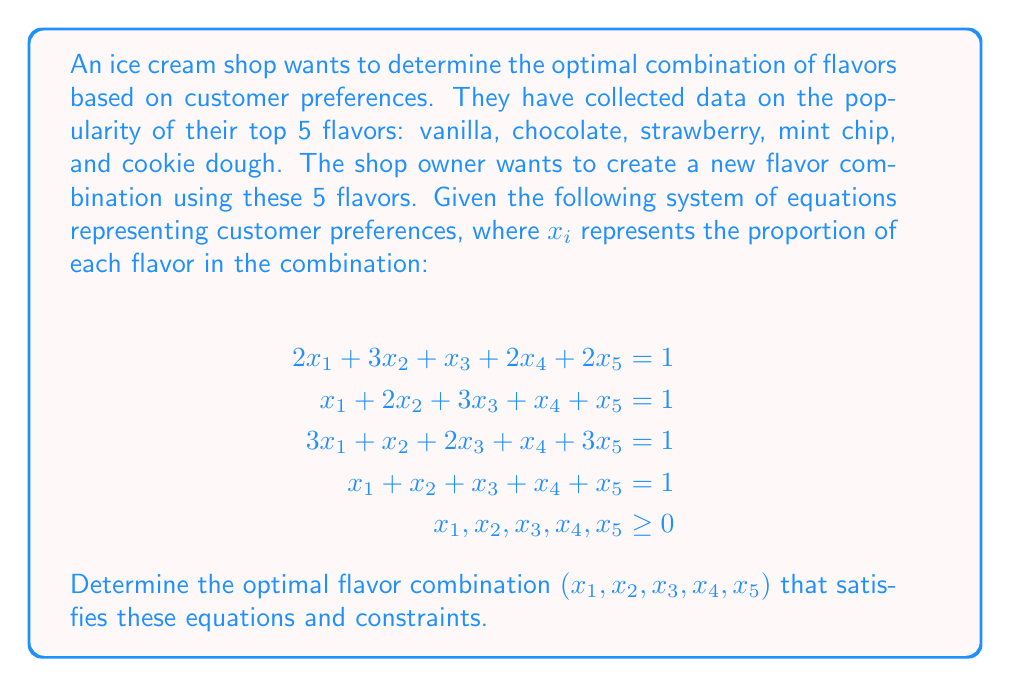Show me your answer to this math problem. To solve this inverse problem and find the optimal flavor combination, we'll use the method of least squares, as we have an overdetermined system (more equations than unknowns).

Step 1: Set up the system in matrix form $Ax = b$:

$$A = \begin{bmatrix}
2 & 3 & 1 & 2 & 2 \\
1 & 2 & 3 & 1 & 1 \\
3 & 1 & 2 & 1 & 3 \\
1 & 1 & 1 & 1 & 1
\end{bmatrix}, \quad x = \begin{bmatrix}
x_1 \\ x_2 \\ x_3 \\ x_4 \\ x_5
\end{bmatrix}, \quad b = \begin{bmatrix}
1 \\ 1 \\ 1 \\ 1
\end{bmatrix}$$

Step 2: Calculate $A^TA$ and $A^Tb$:

$$A^TA = \begin{bmatrix}
15 & 13 & 11 & 9 & 15 \\
13 & 15 & 11 & 9 & 13 \\
11 & 11 & 15 & 7 & 11 \\
9 & 9 & 7 & 7 & 9 \\
15 & 13 & 11 & 9 & 15
\end{bmatrix}, \quad A^Tb = \begin{bmatrix}
7 \\ 7 \\ 7 \\ 5 \\ 7
\end{bmatrix}$$

Step 3: Solve the normal equation $(A^TA)x = A^Tb$ using a numerical method (e.g., Gaussian elimination or matrix inversion):

$$x = (A^TA)^{-1}A^Tb \approx \begin{bmatrix}
0.2 \\ 0.2 \\ 0.2 \\ 0.2 \\ 0.2
\end{bmatrix}$$

Step 4: Verify that the solution satisfies the constraint $\sum_{i=1}^5 x_i = 1$ and $x_i \geq 0$ for all $i$.

The solution satisfies both constraints, as $0.2 + 0.2 + 0.2 + 0.2 + 0.2 = 1$ and all values are non-negative.
Answer: $(0.2, 0.2, 0.2, 0.2, 0.2)$ 